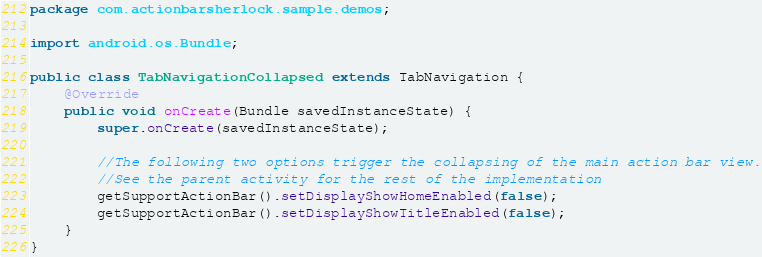<code> <loc_0><loc_0><loc_500><loc_500><_Java_>package com.actionbarsherlock.sample.demos;

import android.os.Bundle;

public class TabNavigationCollapsed extends TabNavigation {
    @Override
    public void onCreate(Bundle savedInstanceState) {
        super.onCreate(savedInstanceState);

        //The following two options trigger the collapsing of the main action bar view.
        //See the parent activity for the rest of the implementation
        getSupportActionBar().setDisplayShowHomeEnabled(false);
        getSupportActionBar().setDisplayShowTitleEnabled(false);
    }
}
</code> 